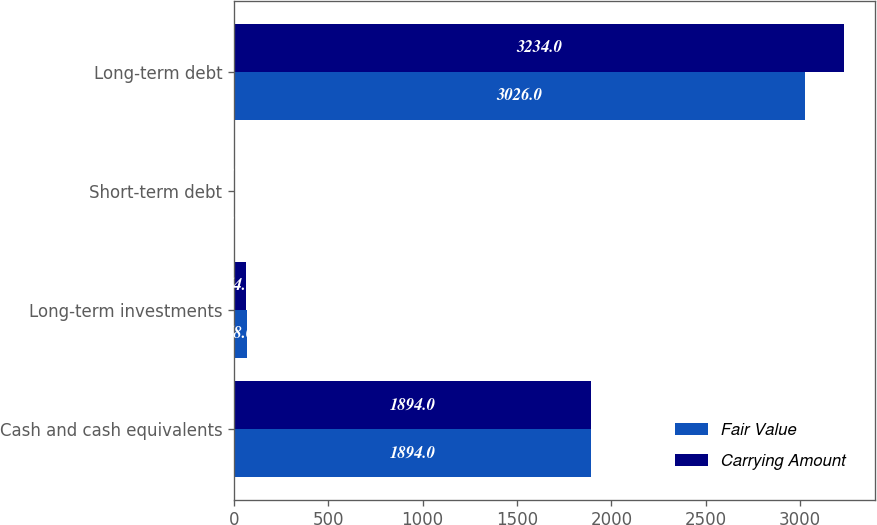Convert chart to OTSL. <chart><loc_0><loc_0><loc_500><loc_500><stacked_bar_chart><ecel><fcel>Cash and cash equivalents<fcel>Long-term investments<fcel>Short-term debt<fcel>Long-term debt<nl><fcel>Fair Value<fcel>1894<fcel>68<fcel>8<fcel>3026<nl><fcel>Carrying Amount<fcel>1894<fcel>64<fcel>8<fcel>3234<nl></chart> 